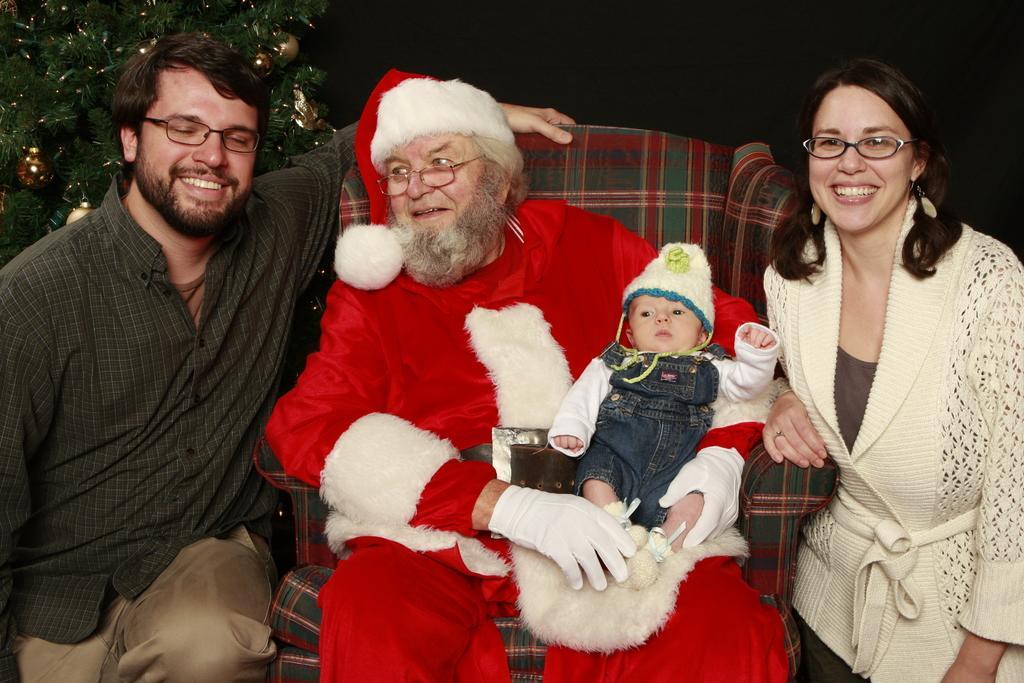Describe this image in one or two sentences. In this picture we can see three people and one person is sitting on a chair and wearing a costume, here we can see a child on a person, at the back of them we can see a Christmas tree and in the background we can see it is dark. 